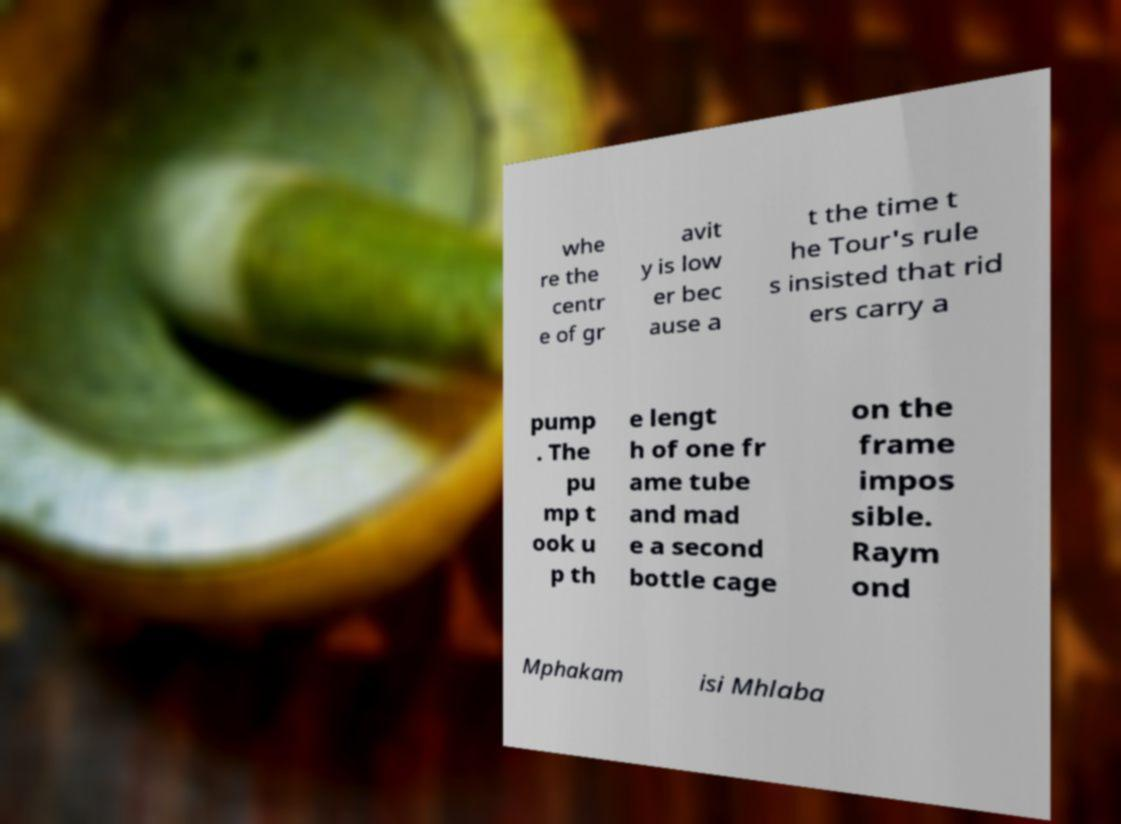Please read and relay the text visible in this image. What does it say? whe re the centr e of gr avit y is low er bec ause a t the time t he Tour's rule s insisted that rid ers carry a pump . The pu mp t ook u p th e lengt h of one fr ame tube and mad e a second bottle cage on the frame impos sible. Raym ond Mphakam isi Mhlaba 